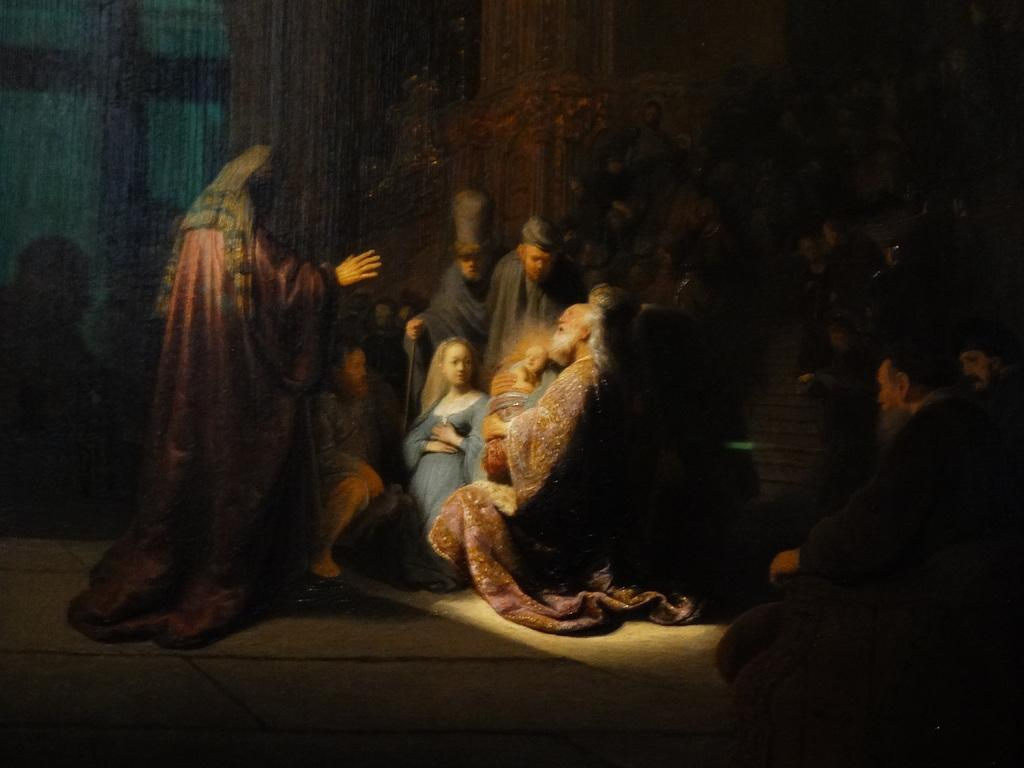What is featured in the image? There is a poster in the image. Where are the people located in the image? The people are in the center of the image. What can be seen in the background of the image? There are curtains in the background of the image. What type of crate is being used to transport the eggs in the image? There is no crate or eggs present in the image; it only features a poster and people in the center. What disease is being discussed by the people in the image? There is no indication of a disease being discussed in the image, as it only features a poster and people in the center. 